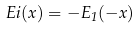<formula> <loc_0><loc_0><loc_500><loc_500>E i ( x ) = - E _ { 1 } ( - x )</formula> 